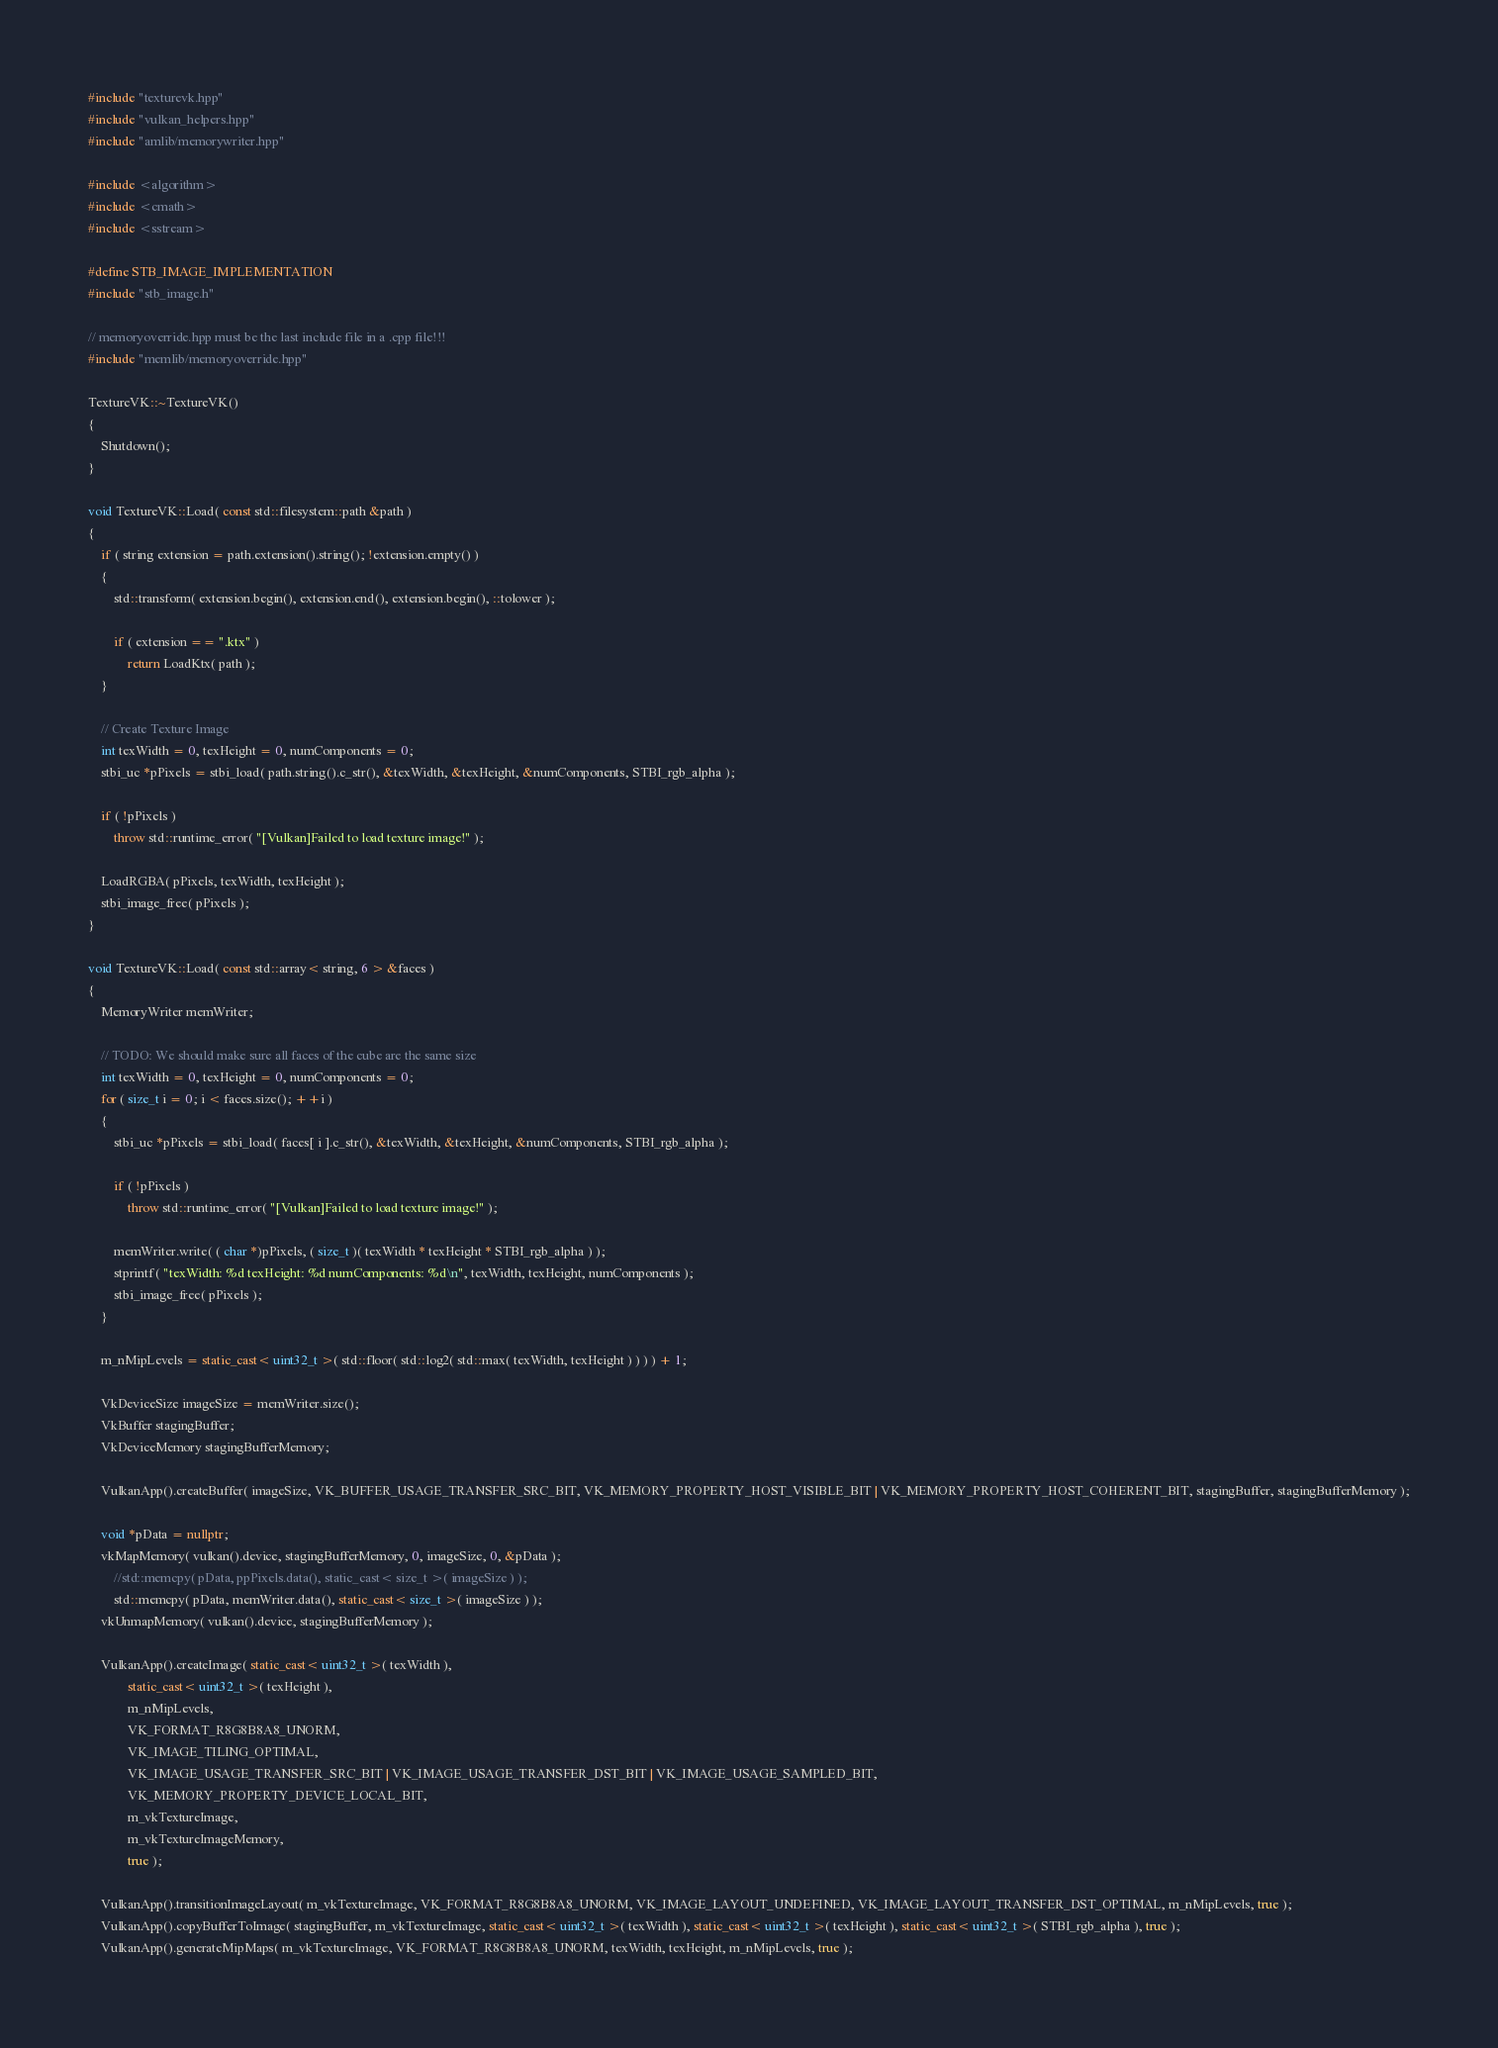<code> <loc_0><loc_0><loc_500><loc_500><_C++_>#include "texturevk.hpp"
#include "vulkan_helpers.hpp"
#include "amlib/memorywriter.hpp"

#include <algorithm>
#include <cmath>
#include <sstream>

#define STB_IMAGE_IMPLEMENTATION
#include "stb_image.h"

// memoryoverride.hpp must be the last include file in a .cpp file!!!
#include "memlib/memoryoverride.hpp"

TextureVK::~TextureVK()
{
	Shutdown();
}

void TextureVK::Load( const std::filesystem::path &path )
{
	if ( string extension = path.extension().string(); !extension.empty() )
	{
		std::transform( extension.begin(), extension.end(), extension.begin(), ::tolower );

		if ( extension == ".ktx" )
			return LoadKtx( path );
	}

	// Create Texture Image
	int texWidth = 0, texHeight = 0, numComponents = 0;
	stbi_uc *pPixels = stbi_load( path.string().c_str(), &texWidth, &texHeight, &numComponents, STBI_rgb_alpha );

	if ( !pPixels )
		throw std::runtime_error( "[Vulkan]Failed to load texture image!" );

	LoadRGBA( pPixels, texWidth, texHeight );
	stbi_image_free( pPixels );
}

void TextureVK::Load( const std::array< string, 6 > &faces )
{
	MemoryWriter memWriter;

	// TODO: We should make sure all faces of the cube are the same size
	int texWidth = 0, texHeight = 0, numComponents = 0;
	for ( size_t i = 0; i < faces.size(); ++i )
	{
		stbi_uc *pPixels = stbi_load( faces[ i ].c_str(), &texWidth, &texHeight, &numComponents, STBI_rgb_alpha );

		if ( !pPixels )
			throw std::runtime_error( "[Vulkan]Failed to load texture image!" );

		memWriter.write( ( char *)pPixels, ( size_t )( texWidth * texHeight * STBI_rgb_alpha ) );
		stprintf( "texWidth: %d texHeight: %d numComponents: %d\n", texWidth, texHeight, numComponents );
		stbi_image_free( pPixels );
	}

	m_nMipLevels = static_cast< uint32_t >( std::floor( std::log2( std::max( texWidth, texHeight ) ) ) ) + 1;

	VkDeviceSize imageSize = memWriter.size();
	VkBuffer stagingBuffer;
	VkDeviceMemory stagingBufferMemory;

	VulkanApp().createBuffer( imageSize, VK_BUFFER_USAGE_TRANSFER_SRC_BIT, VK_MEMORY_PROPERTY_HOST_VISIBLE_BIT | VK_MEMORY_PROPERTY_HOST_COHERENT_BIT, stagingBuffer, stagingBufferMemory );

	void *pData = nullptr;
	vkMapMemory( vulkan().device, stagingBufferMemory, 0, imageSize, 0, &pData );
		//std::memcpy( pData, ppPixels.data(), static_cast< size_t >( imageSize ) );
		std::memcpy( pData, memWriter.data(), static_cast< size_t >( imageSize ) );
	vkUnmapMemory( vulkan().device, stagingBufferMemory );

	VulkanApp().createImage( static_cast< uint32_t >( texWidth ),
			static_cast< uint32_t >( texHeight ),
			m_nMipLevels,
			VK_FORMAT_R8G8B8A8_UNORM,
			VK_IMAGE_TILING_OPTIMAL,
			VK_IMAGE_USAGE_TRANSFER_SRC_BIT | VK_IMAGE_USAGE_TRANSFER_DST_BIT | VK_IMAGE_USAGE_SAMPLED_BIT,
			VK_MEMORY_PROPERTY_DEVICE_LOCAL_BIT,
			m_vkTextureImage,
			m_vkTextureImageMemory,
			true );

	VulkanApp().transitionImageLayout( m_vkTextureImage, VK_FORMAT_R8G8B8A8_UNORM, VK_IMAGE_LAYOUT_UNDEFINED, VK_IMAGE_LAYOUT_TRANSFER_DST_OPTIMAL, m_nMipLevels, true );
	VulkanApp().copyBufferToImage( stagingBuffer, m_vkTextureImage, static_cast< uint32_t >( texWidth ), static_cast< uint32_t >( texHeight ), static_cast< uint32_t >( STBI_rgb_alpha ), true );
	VulkanApp().generateMipMaps( m_vkTextureImage, VK_FORMAT_R8G8B8A8_UNORM, texWidth, texHeight, m_nMipLevels, true );
</code> 